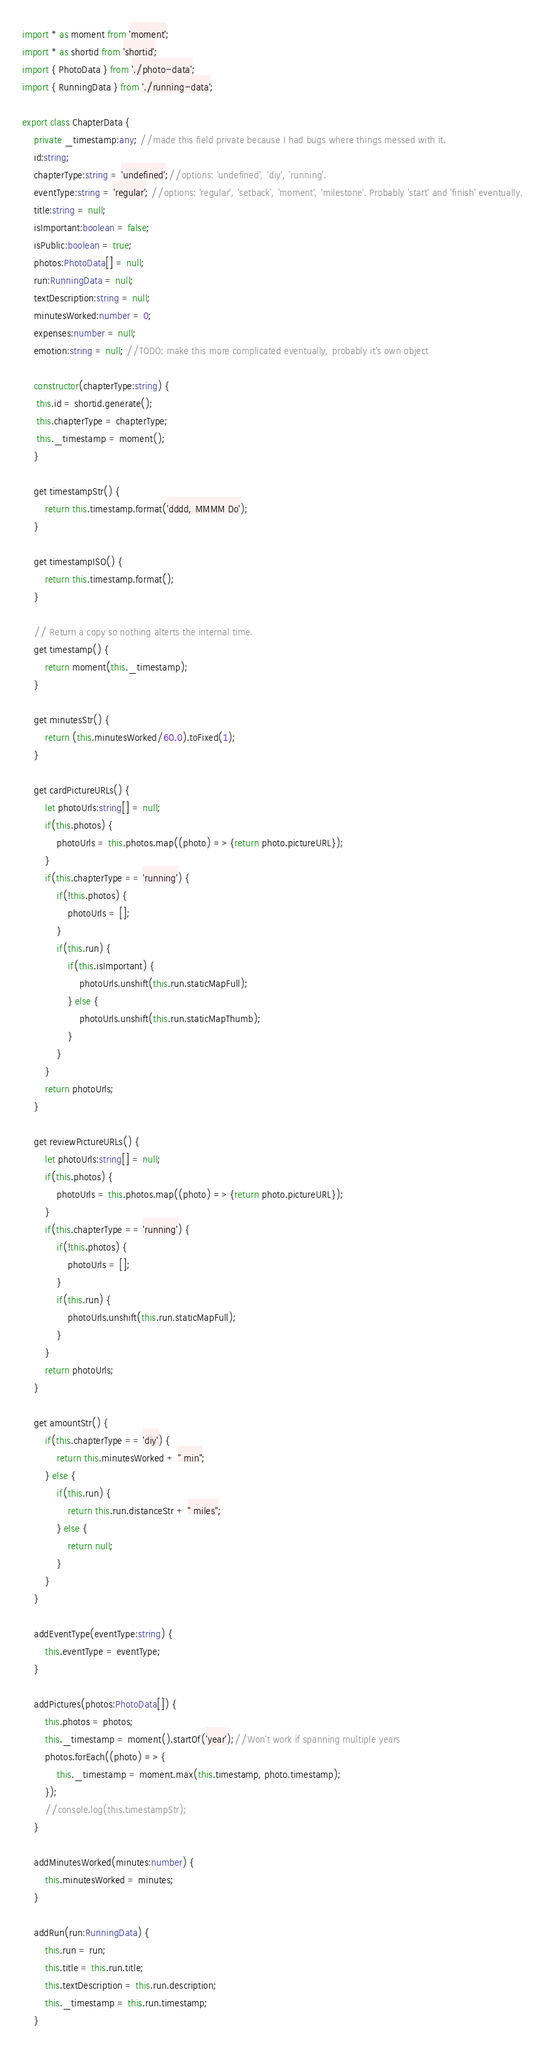<code> <loc_0><loc_0><loc_500><loc_500><_TypeScript_>import * as moment from 'moment';
import * as shortid from 'shortid';
import { PhotoData } from './photo-data';
import { RunningData } from './running-data';

export class ChapterData {
    private _timestamp:any; //made this field private because I had bugs where things messed with it.
    id:string;
    chapterType:string = 'undefined';//options: 'undefined', 'diy', 'running'.
    eventType:string = 'regular'; //options: 'regular', 'setback', 'moment', 'milestone'. Probably 'start' and 'finish' eventually.
    title:string = null;
    isImportant:boolean = false;
    isPublic:boolean = true;
    photos:PhotoData[] = null;
    run:RunningData = null;
    textDescription:string = null;
    minutesWorked:number = 0;
    expenses:number = null;
    emotion:string = null; //TODO: make this more complicated eventually, probably it's own object

    constructor(chapterType:string) {
     this.id = shortid.generate();
     this.chapterType = chapterType;
     this._timestamp = moment();
    }

    get timestampStr() {
        return this.timestamp.format('dddd, MMMM Do');
    }

    get timestampISO() {
        return this.timestamp.format();
    }

    // Return a copy so nothing alterts the internal time.
    get timestamp() {
        return moment(this._timestamp);
    }

    get minutesStr() {
        return (this.minutesWorked/60.0).toFixed(1);
    }

    get cardPictureURLs() {
        let photoUrls:string[] = null;
        if(this.photos) {
            photoUrls = this.photos.map((photo) => {return photo.pictureURL});
        }
        if(this.chapterType == 'running') {
            if(!this.photos) {
                photoUrls = [];
            }
            if(this.run) {
                if(this.isImportant) {
                    photoUrls.unshift(this.run.staticMapFull);
                } else {
                    photoUrls.unshift(this.run.staticMapThumb);
                }
            }
        }
        return photoUrls;
    }

    get reviewPictureURLs() {
        let photoUrls:string[] = null;
        if(this.photos) {
            photoUrls = this.photos.map((photo) => {return photo.pictureURL});
        }
        if(this.chapterType == 'running') {
            if(!this.photos) {
                photoUrls = [];
            }
            if(this.run) {
                photoUrls.unshift(this.run.staticMapFull);
            }
        }
        return photoUrls;
    }

    get amountStr() {
        if(this.chapterType == 'diy') {
            return this.minutesWorked + " min";
        } else {
            if(this.run) {
                return this.run.distanceStr + " miles";
            } else {
                return null;
            }
        }
    }

    addEventType(eventType:string) {
        this.eventType = eventType;
    }
    
    addPictures(photos:PhotoData[]) {
        this.photos = photos;
        this._timestamp = moment().startOf('year');//Won't work if spanning multiple years
        photos.forEach((photo) => {
            this._timestamp = moment.max(this.timestamp, photo.timestamp);
        });
        //console.log(this.timestampStr);
    }

    addMinutesWorked(minutes:number) {
        this.minutesWorked = minutes;
    }

    addRun(run:RunningData) {
        this.run = run;
        this.title = this.run.title;
        this.textDescription = this.run.description;
        this._timestamp = this.run.timestamp;
    }
</code> 